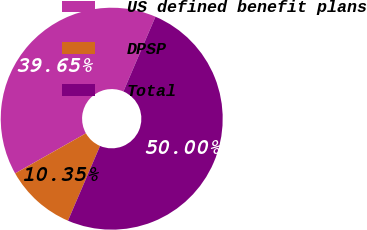Convert chart. <chart><loc_0><loc_0><loc_500><loc_500><pie_chart><fcel>US defined benefit plans<fcel>DPSP<fcel>Total<nl><fcel>39.65%<fcel>10.35%<fcel>50.0%<nl></chart> 